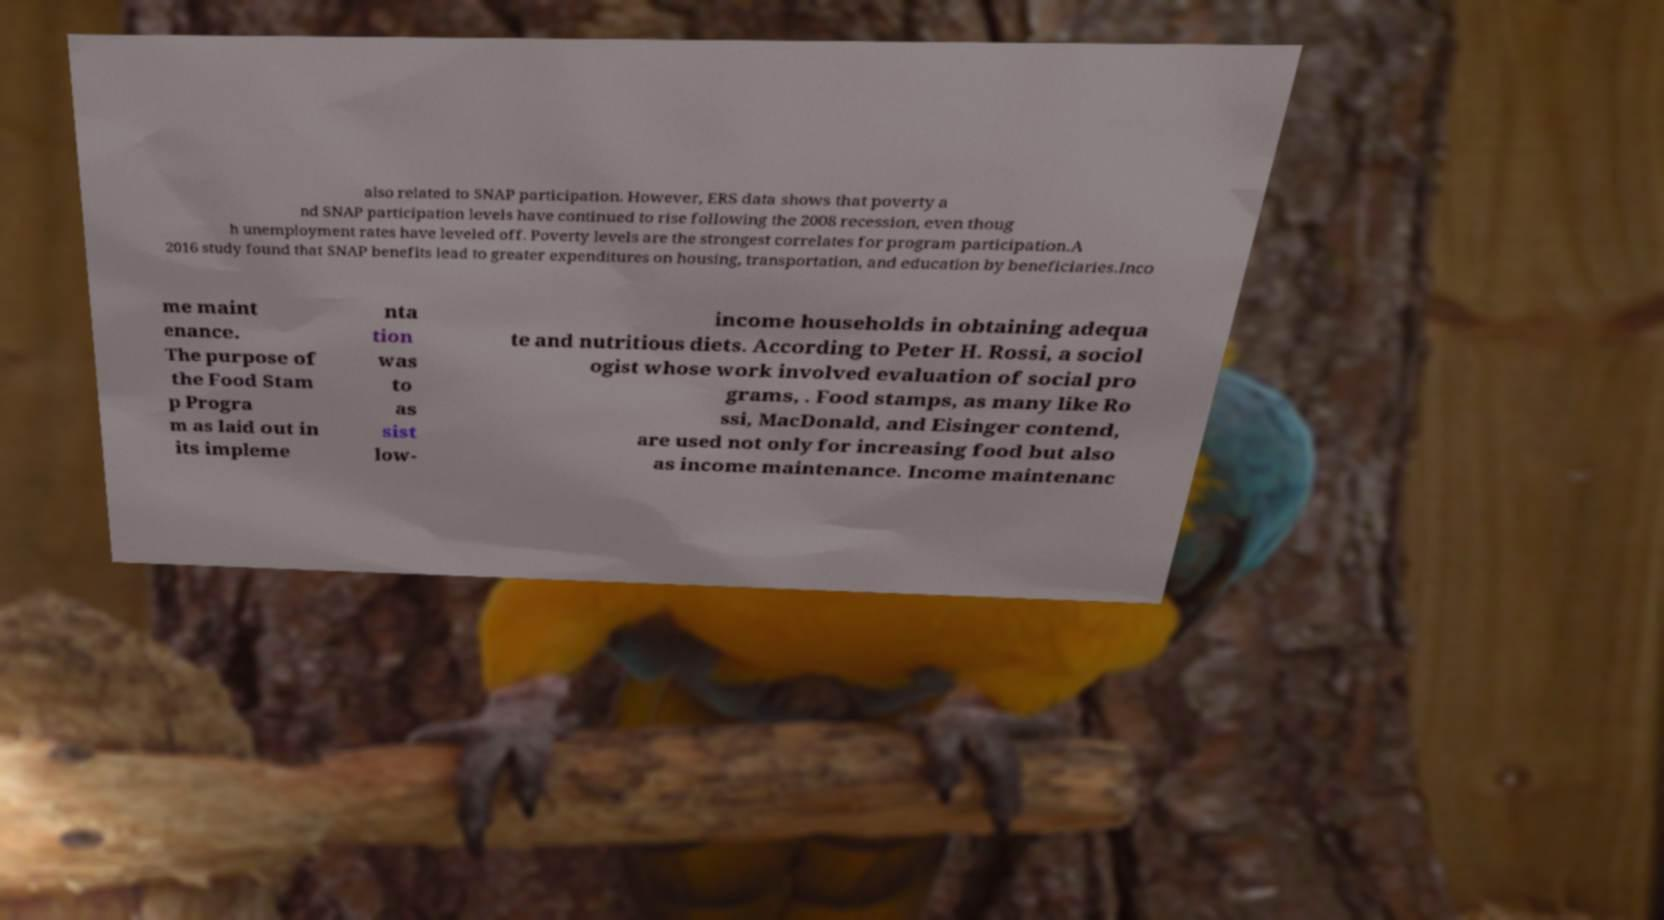Could you assist in decoding the text presented in this image and type it out clearly? also related to SNAP participation. However, ERS data shows that poverty a nd SNAP participation levels have continued to rise following the 2008 recession, even thoug h unemployment rates have leveled off. Poverty levels are the strongest correlates for program participation.A 2016 study found that SNAP benefits lead to greater expenditures on housing, transportation, and education by beneficiaries.Inco me maint enance. The purpose of the Food Stam p Progra m as laid out in its impleme nta tion was to as sist low- income households in obtaining adequa te and nutritious diets. According to Peter H. Rossi, a sociol ogist whose work involved evaluation of social pro grams, . Food stamps, as many like Ro ssi, MacDonald, and Eisinger contend, are used not only for increasing food but also as income maintenance. Income maintenanc 